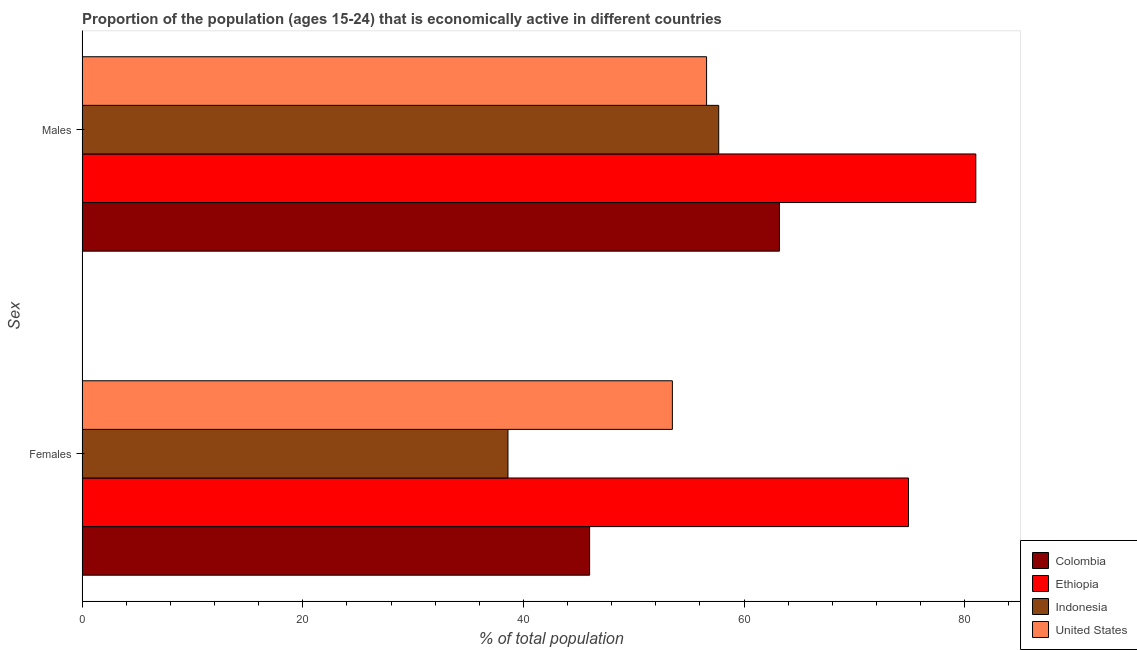How many different coloured bars are there?
Give a very brief answer. 4. How many groups of bars are there?
Ensure brevity in your answer.  2. Are the number of bars per tick equal to the number of legend labels?
Your answer should be compact. Yes. How many bars are there on the 2nd tick from the top?
Offer a terse response. 4. How many bars are there on the 1st tick from the bottom?
Give a very brief answer. 4. What is the label of the 1st group of bars from the top?
Give a very brief answer. Males. What is the percentage of economically active female population in United States?
Your answer should be very brief. 53.5. Across all countries, what is the maximum percentage of economically active female population?
Provide a succinct answer. 74.9. Across all countries, what is the minimum percentage of economically active female population?
Provide a short and direct response. 38.6. In which country was the percentage of economically active female population maximum?
Provide a short and direct response. Ethiopia. In which country was the percentage of economically active male population minimum?
Offer a very short reply. United States. What is the total percentage of economically active male population in the graph?
Your response must be concise. 258.5. What is the difference between the percentage of economically active male population in Indonesia and that in Colombia?
Offer a terse response. -5.5. What is the difference between the percentage of economically active male population in Colombia and the percentage of economically active female population in Ethiopia?
Provide a succinct answer. -11.7. What is the average percentage of economically active male population per country?
Your answer should be very brief. 64.63. What is the difference between the percentage of economically active male population and percentage of economically active female population in Ethiopia?
Provide a succinct answer. 6.1. In how many countries, is the percentage of economically active female population greater than 44 %?
Provide a short and direct response. 3. What is the ratio of the percentage of economically active female population in United States to that in Colombia?
Provide a short and direct response. 1.16. Is the percentage of economically active female population in Indonesia less than that in Colombia?
Offer a very short reply. Yes. In how many countries, is the percentage of economically active female population greater than the average percentage of economically active female population taken over all countries?
Your answer should be very brief. 2. What does the 3rd bar from the bottom in Males represents?
Give a very brief answer. Indonesia. How many countries are there in the graph?
Offer a terse response. 4. What is the difference between two consecutive major ticks on the X-axis?
Offer a very short reply. 20. Are the values on the major ticks of X-axis written in scientific E-notation?
Your response must be concise. No. Where does the legend appear in the graph?
Offer a terse response. Bottom right. How many legend labels are there?
Provide a succinct answer. 4. What is the title of the graph?
Provide a short and direct response. Proportion of the population (ages 15-24) that is economically active in different countries. What is the label or title of the X-axis?
Offer a very short reply. % of total population. What is the label or title of the Y-axis?
Make the answer very short. Sex. What is the % of total population in Colombia in Females?
Ensure brevity in your answer.  46. What is the % of total population in Ethiopia in Females?
Your response must be concise. 74.9. What is the % of total population of Indonesia in Females?
Offer a very short reply. 38.6. What is the % of total population of United States in Females?
Offer a terse response. 53.5. What is the % of total population of Colombia in Males?
Your answer should be compact. 63.2. What is the % of total population of Indonesia in Males?
Your response must be concise. 57.7. What is the % of total population in United States in Males?
Keep it short and to the point. 56.6. Across all Sex, what is the maximum % of total population of Colombia?
Offer a very short reply. 63.2. Across all Sex, what is the maximum % of total population in Indonesia?
Ensure brevity in your answer.  57.7. Across all Sex, what is the maximum % of total population of United States?
Provide a succinct answer. 56.6. Across all Sex, what is the minimum % of total population of Colombia?
Keep it short and to the point. 46. Across all Sex, what is the minimum % of total population in Ethiopia?
Give a very brief answer. 74.9. Across all Sex, what is the minimum % of total population in Indonesia?
Offer a terse response. 38.6. Across all Sex, what is the minimum % of total population of United States?
Keep it short and to the point. 53.5. What is the total % of total population of Colombia in the graph?
Give a very brief answer. 109.2. What is the total % of total population in Ethiopia in the graph?
Your answer should be compact. 155.9. What is the total % of total population of Indonesia in the graph?
Your answer should be compact. 96.3. What is the total % of total population in United States in the graph?
Give a very brief answer. 110.1. What is the difference between the % of total population of Colombia in Females and that in Males?
Offer a very short reply. -17.2. What is the difference between the % of total population of Indonesia in Females and that in Males?
Keep it short and to the point. -19.1. What is the difference between the % of total population in Colombia in Females and the % of total population in Ethiopia in Males?
Give a very brief answer. -35. What is the difference between the % of total population of Colombia in Females and the % of total population of Indonesia in Males?
Provide a succinct answer. -11.7. What is the difference between the % of total population in Colombia in Females and the % of total population in United States in Males?
Give a very brief answer. -10.6. What is the difference between the % of total population in Indonesia in Females and the % of total population in United States in Males?
Give a very brief answer. -18. What is the average % of total population in Colombia per Sex?
Keep it short and to the point. 54.6. What is the average % of total population in Ethiopia per Sex?
Offer a very short reply. 77.95. What is the average % of total population in Indonesia per Sex?
Ensure brevity in your answer.  48.15. What is the average % of total population of United States per Sex?
Make the answer very short. 55.05. What is the difference between the % of total population of Colombia and % of total population of Ethiopia in Females?
Make the answer very short. -28.9. What is the difference between the % of total population in Ethiopia and % of total population in Indonesia in Females?
Offer a very short reply. 36.3. What is the difference between the % of total population of Ethiopia and % of total population of United States in Females?
Provide a short and direct response. 21.4. What is the difference between the % of total population in Indonesia and % of total population in United States in Females?
Your answer should be compact. -14.9. What is the difference between the % of total population of Colombia and % of total population of Ethiopia in Males?
Keep it short and to the point. -17.8. What is the difference between the % of total population of Ethiopia and % of total population of Indonesia in Males?
Offer a terse response. 23.3. What is the difference between the % of total population in Ethiopia and % of total population in United States in Males?
Your answer should be very brief. 24.4. What is the difference between the % of total population in Indonesia and % of total population in United States in Males?
Offer a very short reply. 1.1. What is the ratio of the % of total population in Colombia in Females to that in Males?
Provide a succinct answer. 0.73. What is the ratio of the % of total population in Ethiopia in Females to that in Males?
Your response must be concise. 0.92. What is the ratio of the % of total population in Indonesia in Females to that in Males?
Make the answer very short. 0.67. What is the ratio of the % of total population of United States in Females to that in Males?
Offer a very short reply. 0.95. What is the difference between the highest and the second highest % of total population in Colombia?
Your response must be concise. 17.2. What is the difference between the highest and the second highest % of total population in Indonesia?
Keep it short and to the point. 19.1. What is the difference between the highest and the lowest % of total population in Colombia?
Offer a terse response. 17.2. 